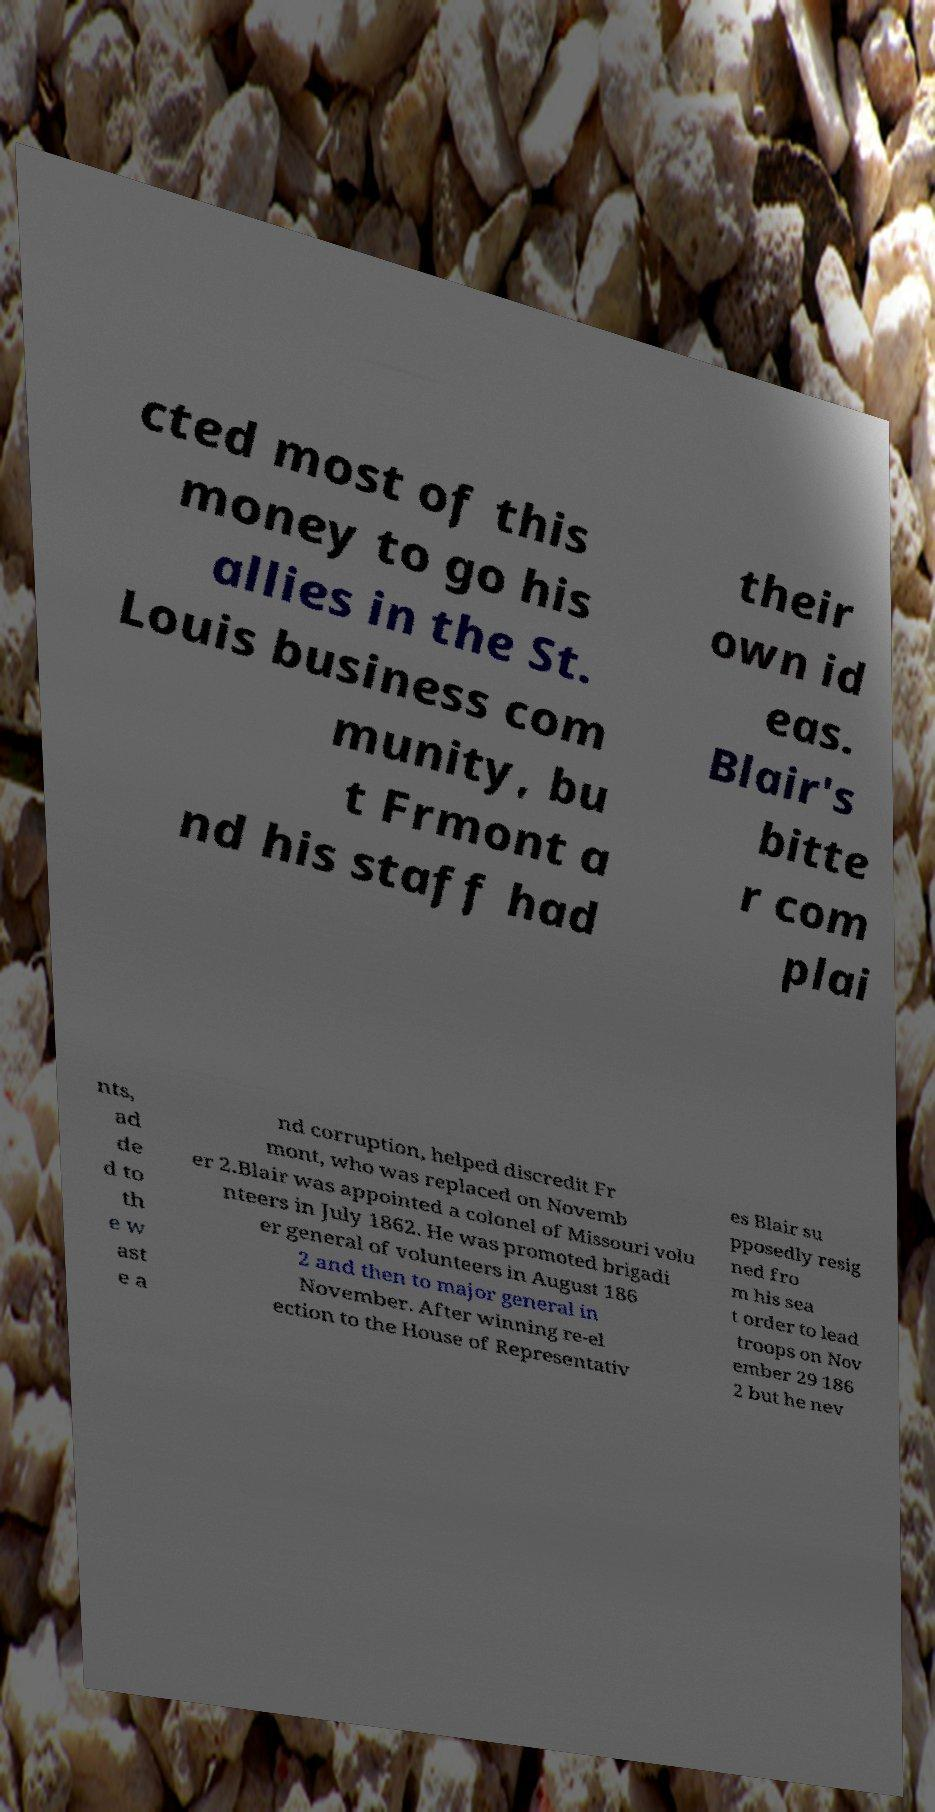I need the written content from this picture converted into text. Can you do that? cted most of this money to go his allies in the St. Louis business com munity, bu t Frmont a nd his staff had their own id eas. Blair's bitte r com plai nts, ad de d to th e w ast e a nd corruption, helped discredit Fr mont, who was replaced on Novemb er 2.Blair was appointed a colonel of Missouri volu nteers in July 1862. He was promoted brigadi er general of volunteers in August 186 2 and then to major general in November. After winning re-el ection to the House of Representativ es Blair su pposedly resig ned fro m his sea t order to lead troops on Nov ember 29 186 2 but he nev 